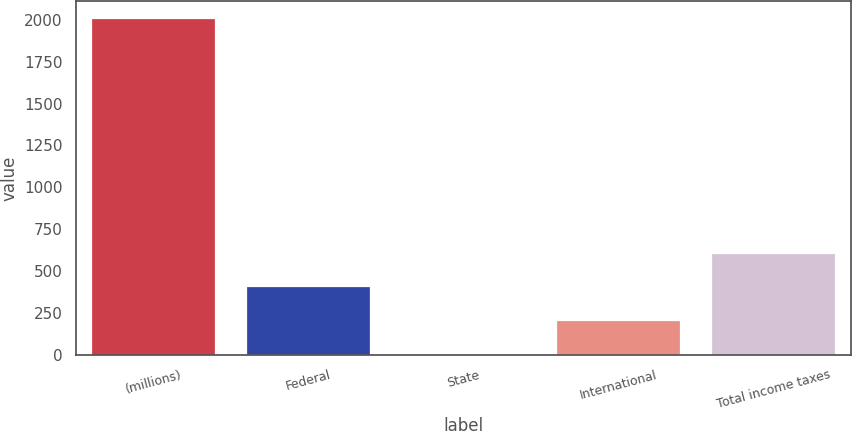Convert chart. <chart><loc_0><loc_0><loc_500><loc_500><bar_chart><fcel>(millions)<fcel>Federal<fcel>State<fcel>International<fcel>Total income taxes<nl><fcel>2012<fcel>410.48<fcel>10.1<fcel>210.29<fcel>610.67<nl></chart> 